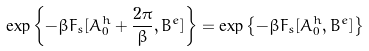<formula> <loc_0><loc_0><loc_500><loc_500>\exp \left \{ - \beta F _ { s } [ A _ { 0 } ^ { h } + \frac { 2 \pi } { \beta } , B ^ { e } ] \right \} = \exp \left \{ - \beta F _ { s } [ A _ { 0 } ^ { h } , B ^ { e } ] \right \}</formula> 